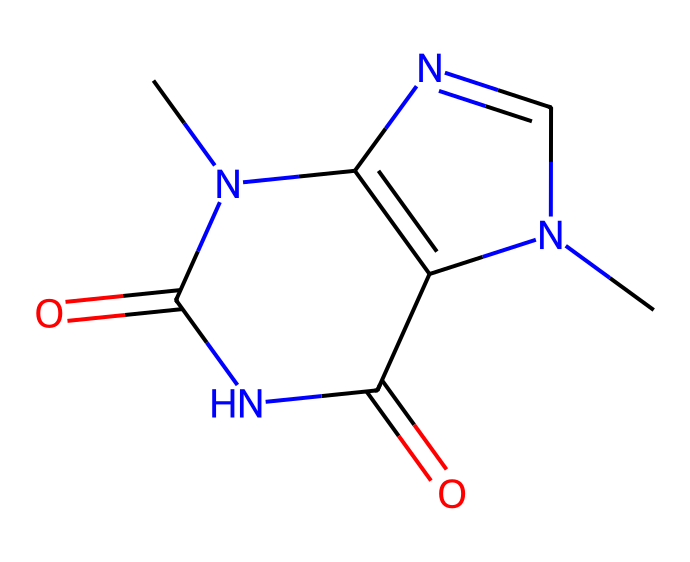What is the molecular formula of theobromine? The SMILES string shows the arrangement of atoms in the chemical, from which the molecular formula can be derived. Counting the elements present, there are 7 carbon atoms, 8 hydrogen atoms, 4 nitrogen atoms, and 2 oxygen atoms. Therefore, the molecular formula is C7H8N4O2.
Answer: C7H8N4O2 How many nitrogen atoms are present in theobromine? By analyzing the SMILES representation, the presence of nitrogen atoms can be counted. There are four nitrogen atoms present in the structure, which can be observed from the formula itself.
Answer: 4 What type of chemical is theobromine classified as? The structure of the chemical and its nitrogen content indicates its classification. The presence of nitrogen and its effect on the central nervous system suggests that theobromine is classified as an alkaloid.
Answer: alkaloid What bonding type is most prominent in theobromine? The chemical structure shows numerous covalent bonds between the atoms, as represented by the absence of metal content and the presence of a framework of carbon and nitrogen atoms. The majority of atoms in the structure are connected via covalent bonds.
Answer: covalent How many rings does the structure of theobromine contain? Analyzing the structure from the SMILES, one can identify that it has a bicyclic structure made up of two fused rings. This characteristic makes it distinct among alkaloids.
Answer: 2 What functional groups are found in theobromine? A careful examination of the SMILES representation reveals the presence of amine (due to nitrogen) and carbonyl groups (due to oxygen). These functional groups contribute to its overall properties and reactivity.
Answer: amine and carbonyl 